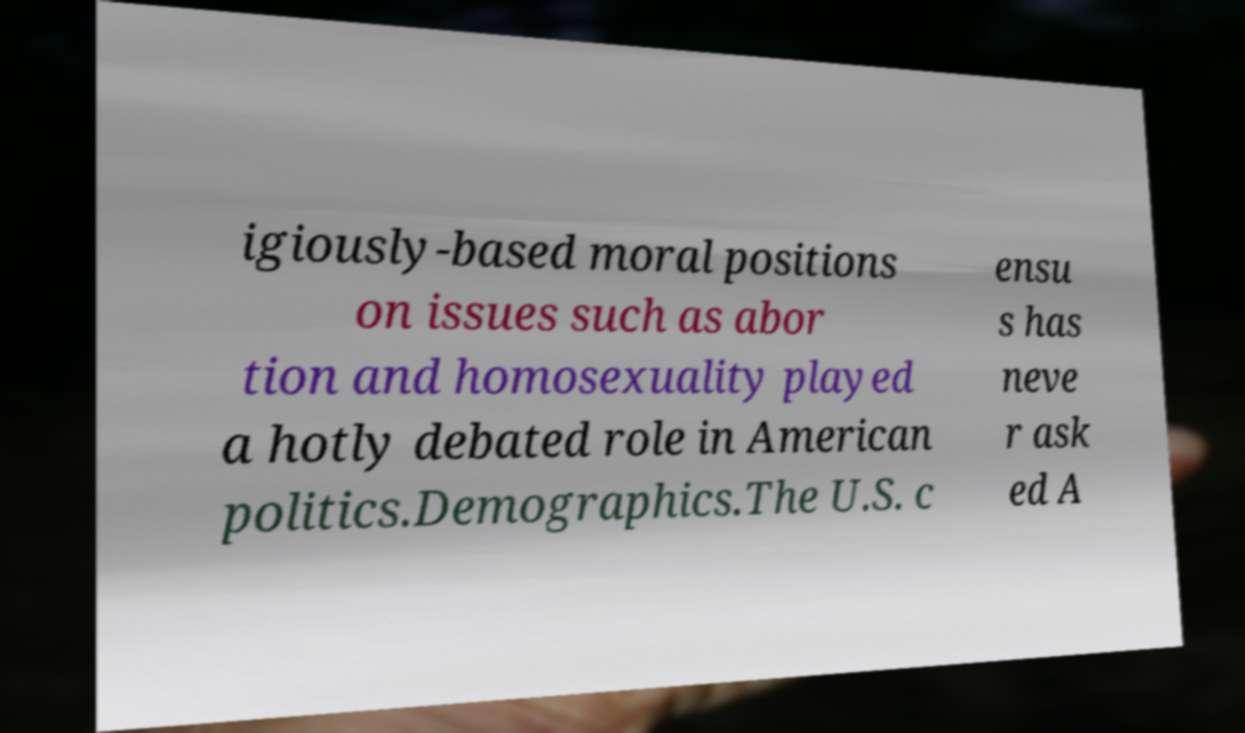Please identify and transcribe the text found in this image. igiously-based moral positions on issues such as abor tion and homosexuality played a hotly debated role in American politics.Demographics.The U.S. c ensu s has neve r ask ed A 